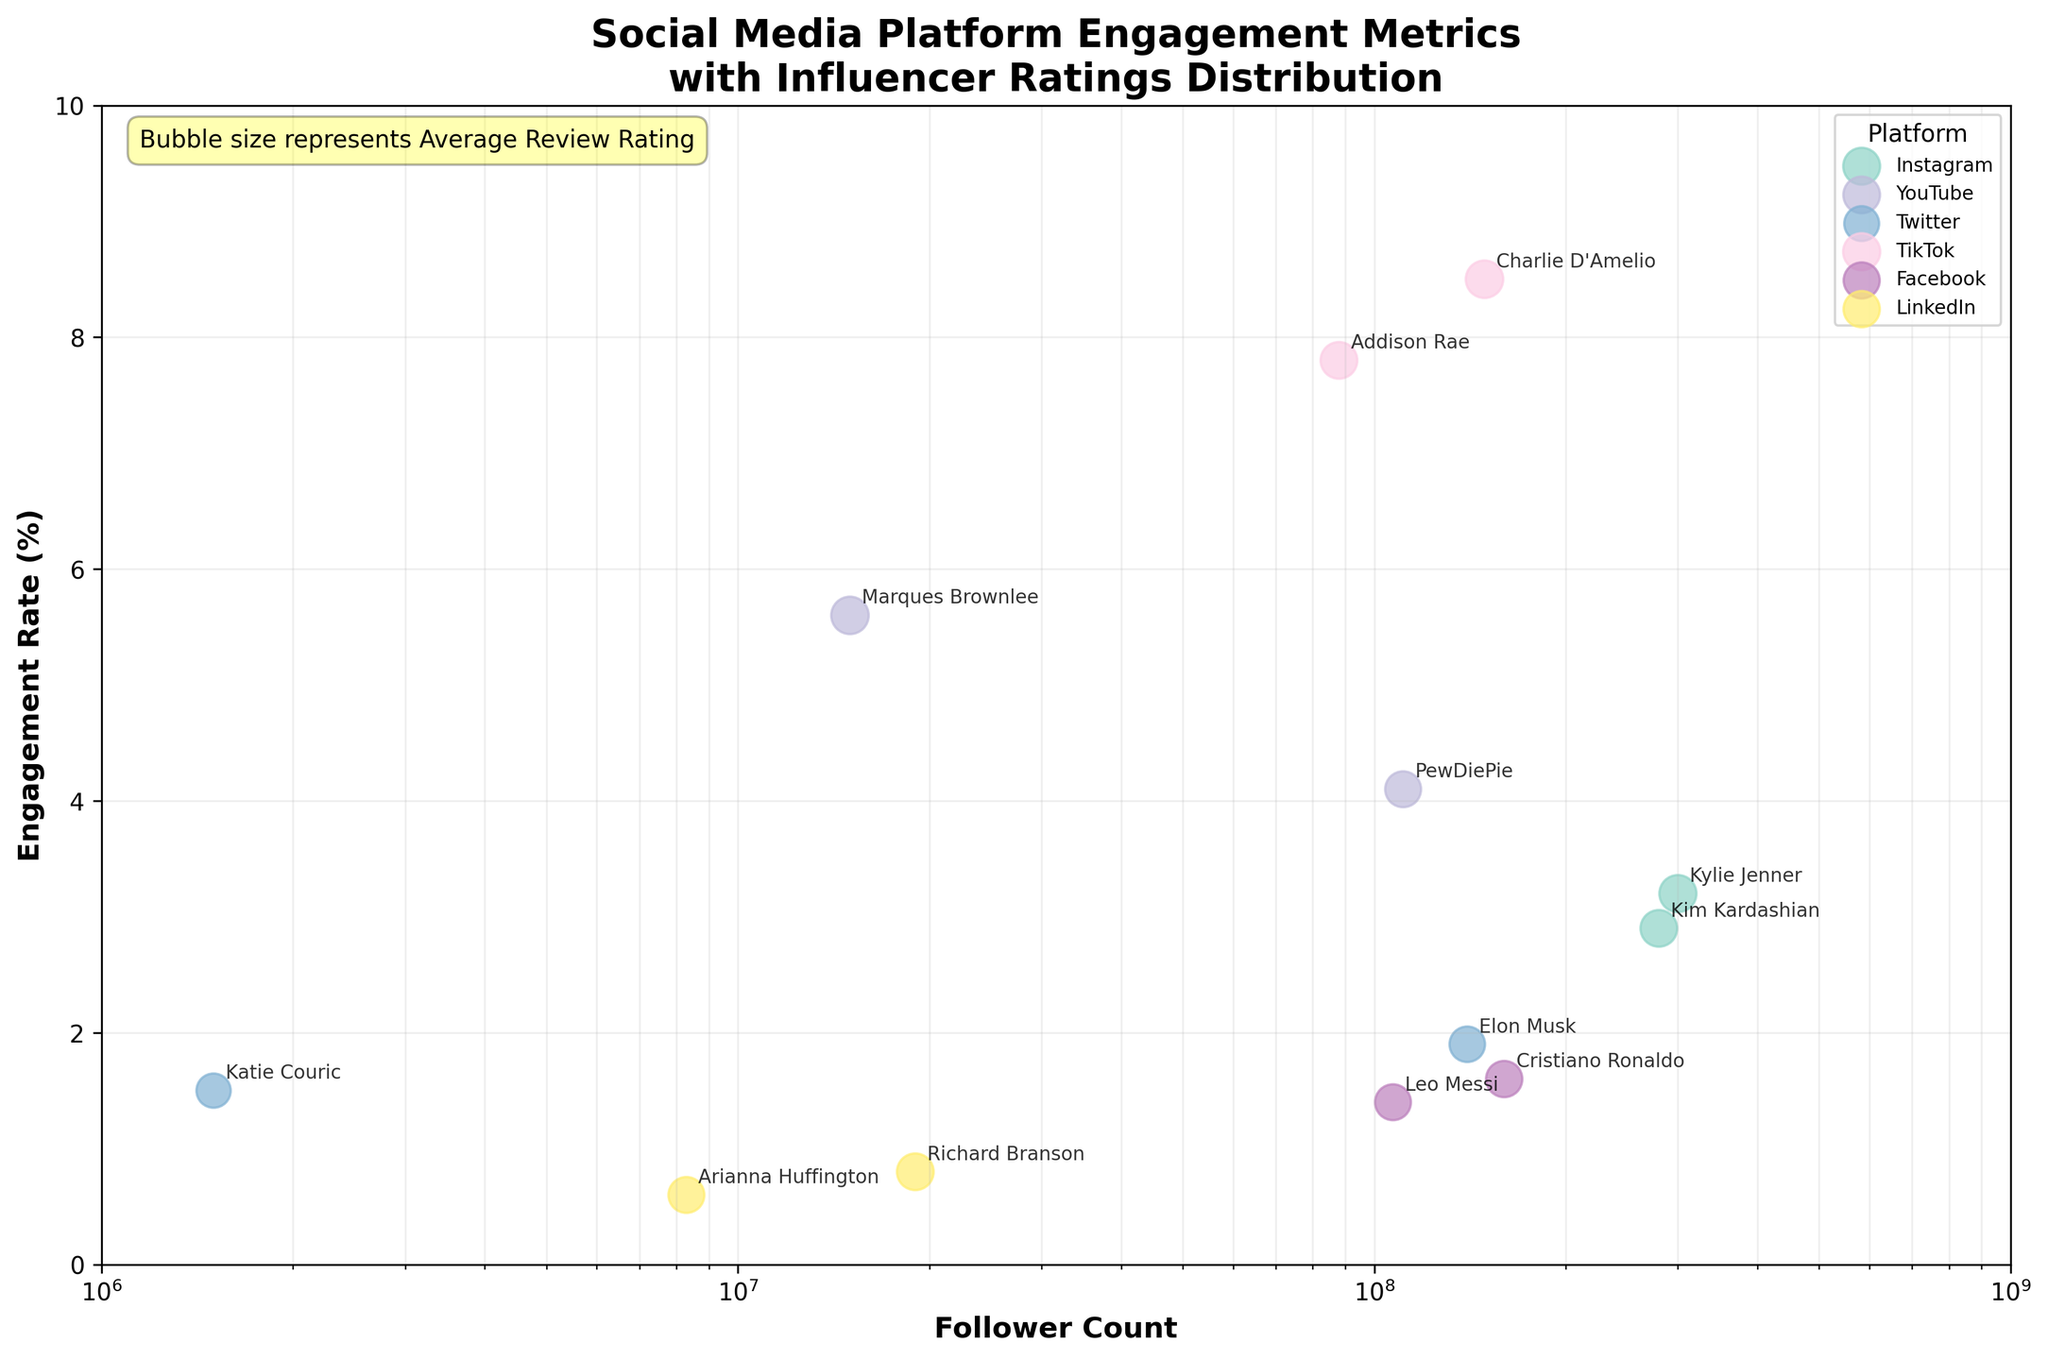What does the title of the figure indicate? The title of the figure provides an overview of the chart's main content: Social Media Platform Engagement Metrics with Influencer Ratings Distribution. This means it shows data regarding engagement rates and follower counts for influencers across different social media platforms, along with their average review ratings.
Answer: Social Media Platform Engagement Metrics with Influencer Ratings Distribution What is the range of the x-axis, and what does it represent? The x-axis range is from 1 million to 1 billion followers, represented on a logarithmic scale. It depicts the follower count for different influencers.
Answer: 1 million to 1 billion followers Which influencer has the highest engagement rate, and what platform are they on? To find the highest engagement rate, look at the highest y-axis value. Charlie D'Amelio on TikTok has the highest engagement rate of 8.5%.
Answer: Charlie D'Amelio, TikTok What does the bubble size represent in the figure? The bubble size indicates the Average Review Rating of the influencers. Larger bubbles represent higher average review ratings.
Answer: Average Review Rating Which platform has the most data points plotted, and how can you tell? By counting the number of bubbles associated with each platform, Instagram has the most data points with 2 influencers.
Answer: Instagram Compare the engagement rates of influencers on Instagram. Who has a higher rate, Kylie Jenner or Kim Kardashian? Kylie Jenner has a higher engagement rate of 3.2% compared to Kim Kardashian's 2.9%.
Answer: Kylie Jenner Which influencer on Twitter has a higher average review rating, Elon Musk or Katie Couric, and by how much? Look at the bubble sizes and annotations. Elon Musk has an average review rating of 4.4, while Katie Couric has 4.1. The difference is 4.4 - 4.1 = 0.3.
Answer: Elon Musk, 0.3 What is the engagement rate for Cristiano Ronaldo on Facebook, and how does it compare to Leo Messi's? Cristiano Ronaldo has an engagement rate of 1.6%, while Leo Messi has 1.4%. Cristiano Ronaldo's engagement rate is higher by 0.2%.
Answer: Cristiano Ronaldo, 0.2% Are there any influencers with the same average review rating on different platforms? By observing the bubble sizes and annotations, Marques Brownlee on YouTube and Charlie D'Amelio on TikTok both have an average review rating of 4.9.
Answer: Yes Do LinkedIn influencers have generally higher or lower engagement rates compared to other platforms? Both LinkedIn influencers, Richard Branson (0.8%) and Arianna Huffington (0.6%), have lower engagement rates compared to influencers on other platforms, whose engagement rates generally range from about 1.4% to 8.5%.
Answer: Lower 